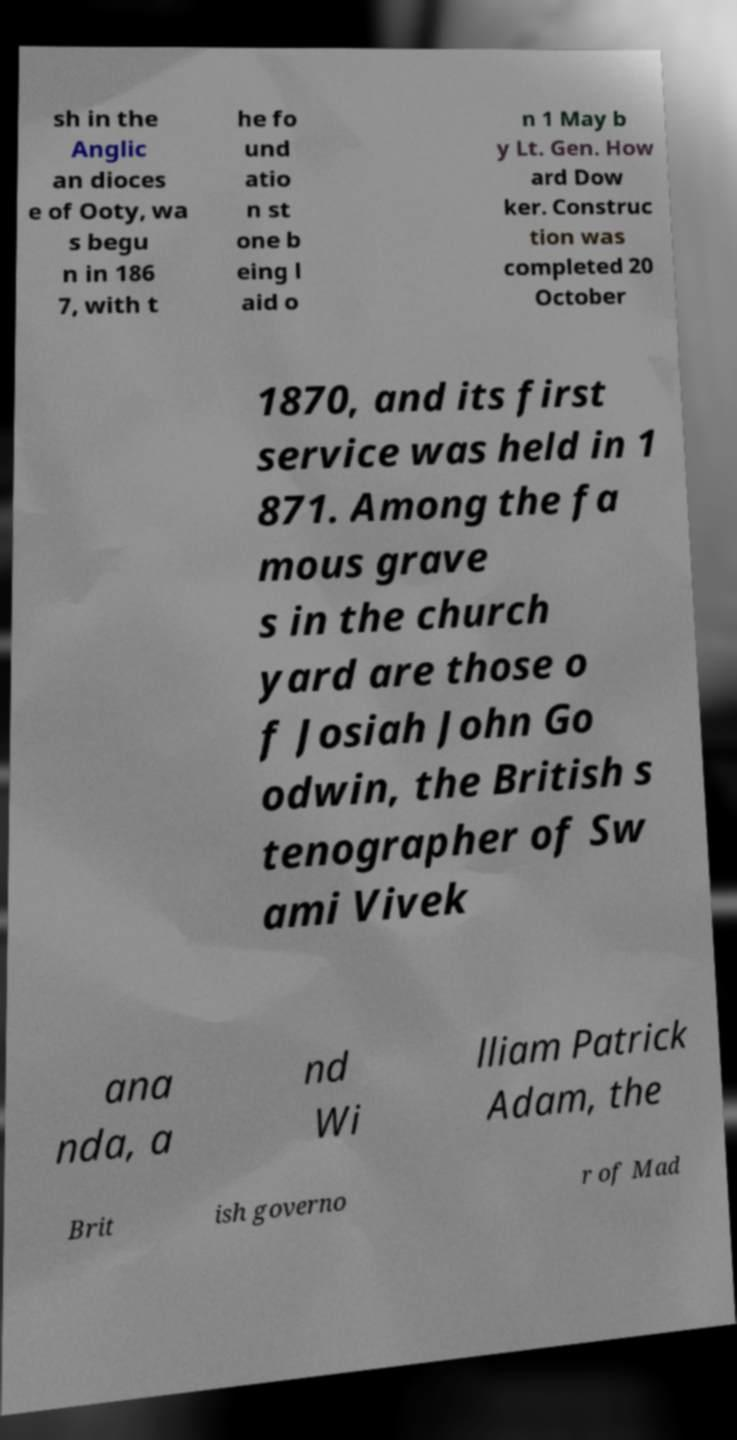Please identify and transcribe the text found in this image. sh in the Anglic an dioces e of Ooty, wa s begu n in 186 7, with t he fo und atio n st one b eing l aid o n 1 May b y Lt. Gen. How ard Dow ker. Construc tion was completed 20 October 1870, and its first service was held in 1 871. Among the fa mous grave s in the church yard are those o f Josiah John Go odwin, the British s tenographer of Sw ami Vivek ana nda, a nd Wi lliam Patrick Adam, the Brit ish governo r of Mad 